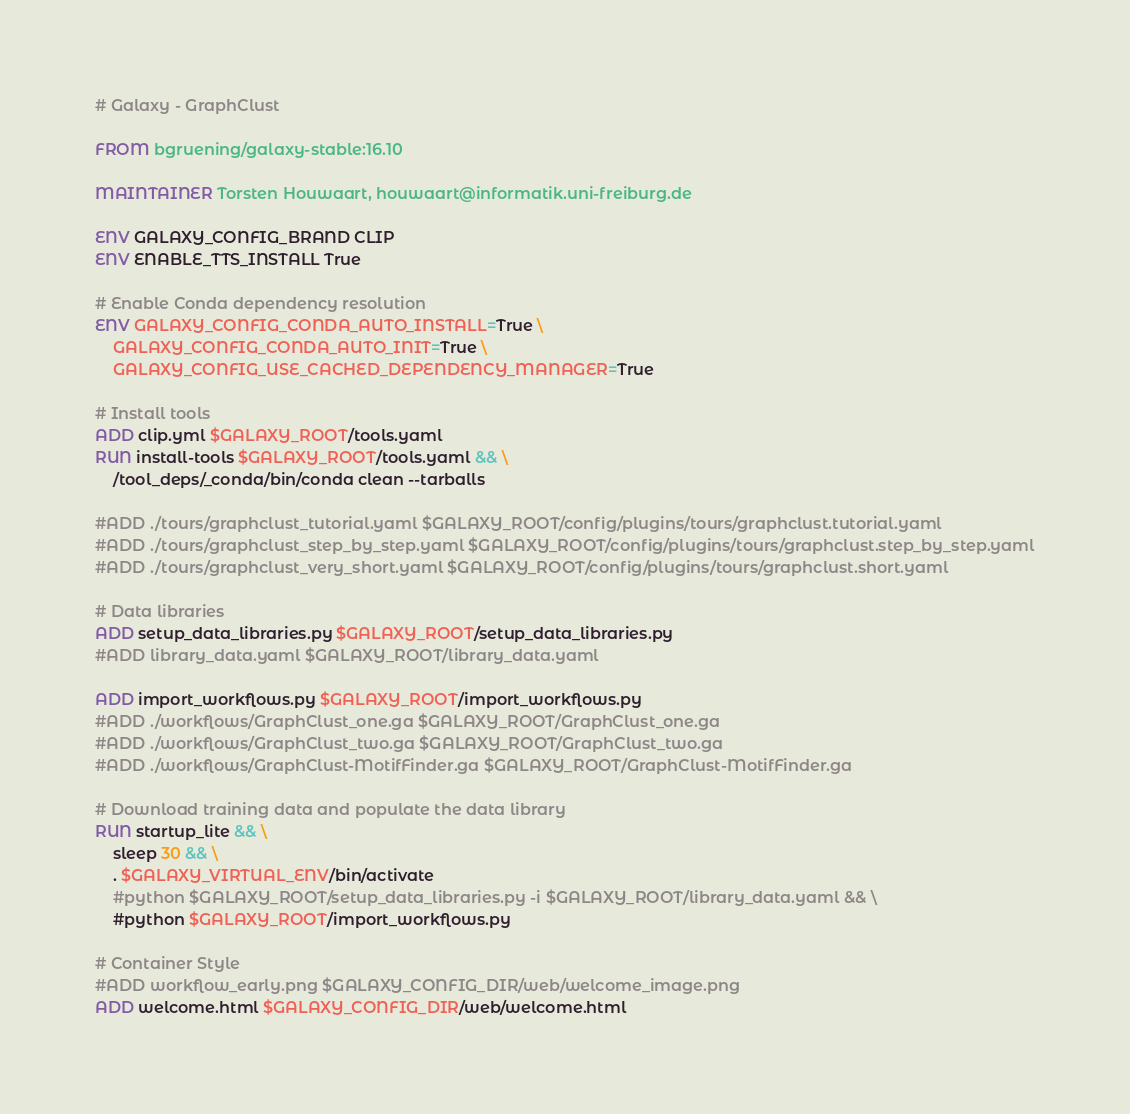<code> <loc_0><loc_0><loc_500><loc_500><_Dockerfile_># Galaxy - GraphClust

FROM bgruening/galaxy-stable:16.10

MAINTAINER Torsten Houwaart, houwaart@informatik.uni-freiburg.de

ENV GALAXY_CONFIG_BRAND CLIP
ENV ENABLE_TTS_INSTALL True

# Enable Conda dependency resolution
ENV GALAXY_CONFIG_CONDA_AUTO_INSTALL=True \
    GALAXY_CONFIG_CONDA_AUTO_INIT=True \
    GALAXY_CONFIG_USE_CACHED_DEPENDENCY_MANAGER=True

# Install tools
ADD clip.yml $GALAXY_ROOT/tools.yaml
RUN install-tools $GALAXY_ROOT/tools.yaml && \
    /tool_deps/_conda/bin/conda clean --tarballs

#ADD ./tours/graphclust_tutorial.yaml $GALAXY_ROOT/config/plugins/tours/graphclust.tutorial.yaml
#ADD ./tours/graphclust_step_by_step.yaml $GALAXY_ROOT/config/plugins/tours/graphclust.step_by_step.yaml
#ADD ./tours/graphclust_very_short.yaml $GALAXY_ROOT/config/plugins/tours/graphclust.short.yaml

# Data libraries
ADD setup_data_libraries.py $GALAXY_ROOT/setup_data_libraries.py
#ADD library_data.yaml $GALAXY_ROOT/library_data.yaml

ADD import_workflows.py $GALAXY_ROOT/import_workflows.py
#ADD ./workflows/GraphClust_one.ga $GALAXY_ROOT/GraphClust_one.ga
#ADD ./workflows/GraphClust_two.ga $GALAXY_ROOT/GraphClust_two.ga
#ADD ./workflows/GraphClust-MotifFinder.ga $GALAXY_ROOT/GraphClust-MotifFinder.ga

# Download training data and populate the data library
RUN startup_lite && \
    sleep 30 && \
    . $GALAXY_VIRTUAL_ENV/bin/activate
    #python $GALAXY_ROOT/setup_data_libraries.py -i $GALAXY_ROOT/library_data.yaml && \
    #python $GALAXY_ROOT/import_workflows.py

# Container Style
#ADD workflow_early.png $GALAXY_CONFIG_DIR/web/welcome_image.png
ADD welcome.html $GALAXY_CONFIG_DIR/web/welcome.html

</code> 